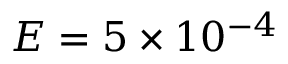<formula> <loc_0><loc_0><loc_500><loc_500>E = 5 \times 1 0 ^ { - 4 }</formula> 